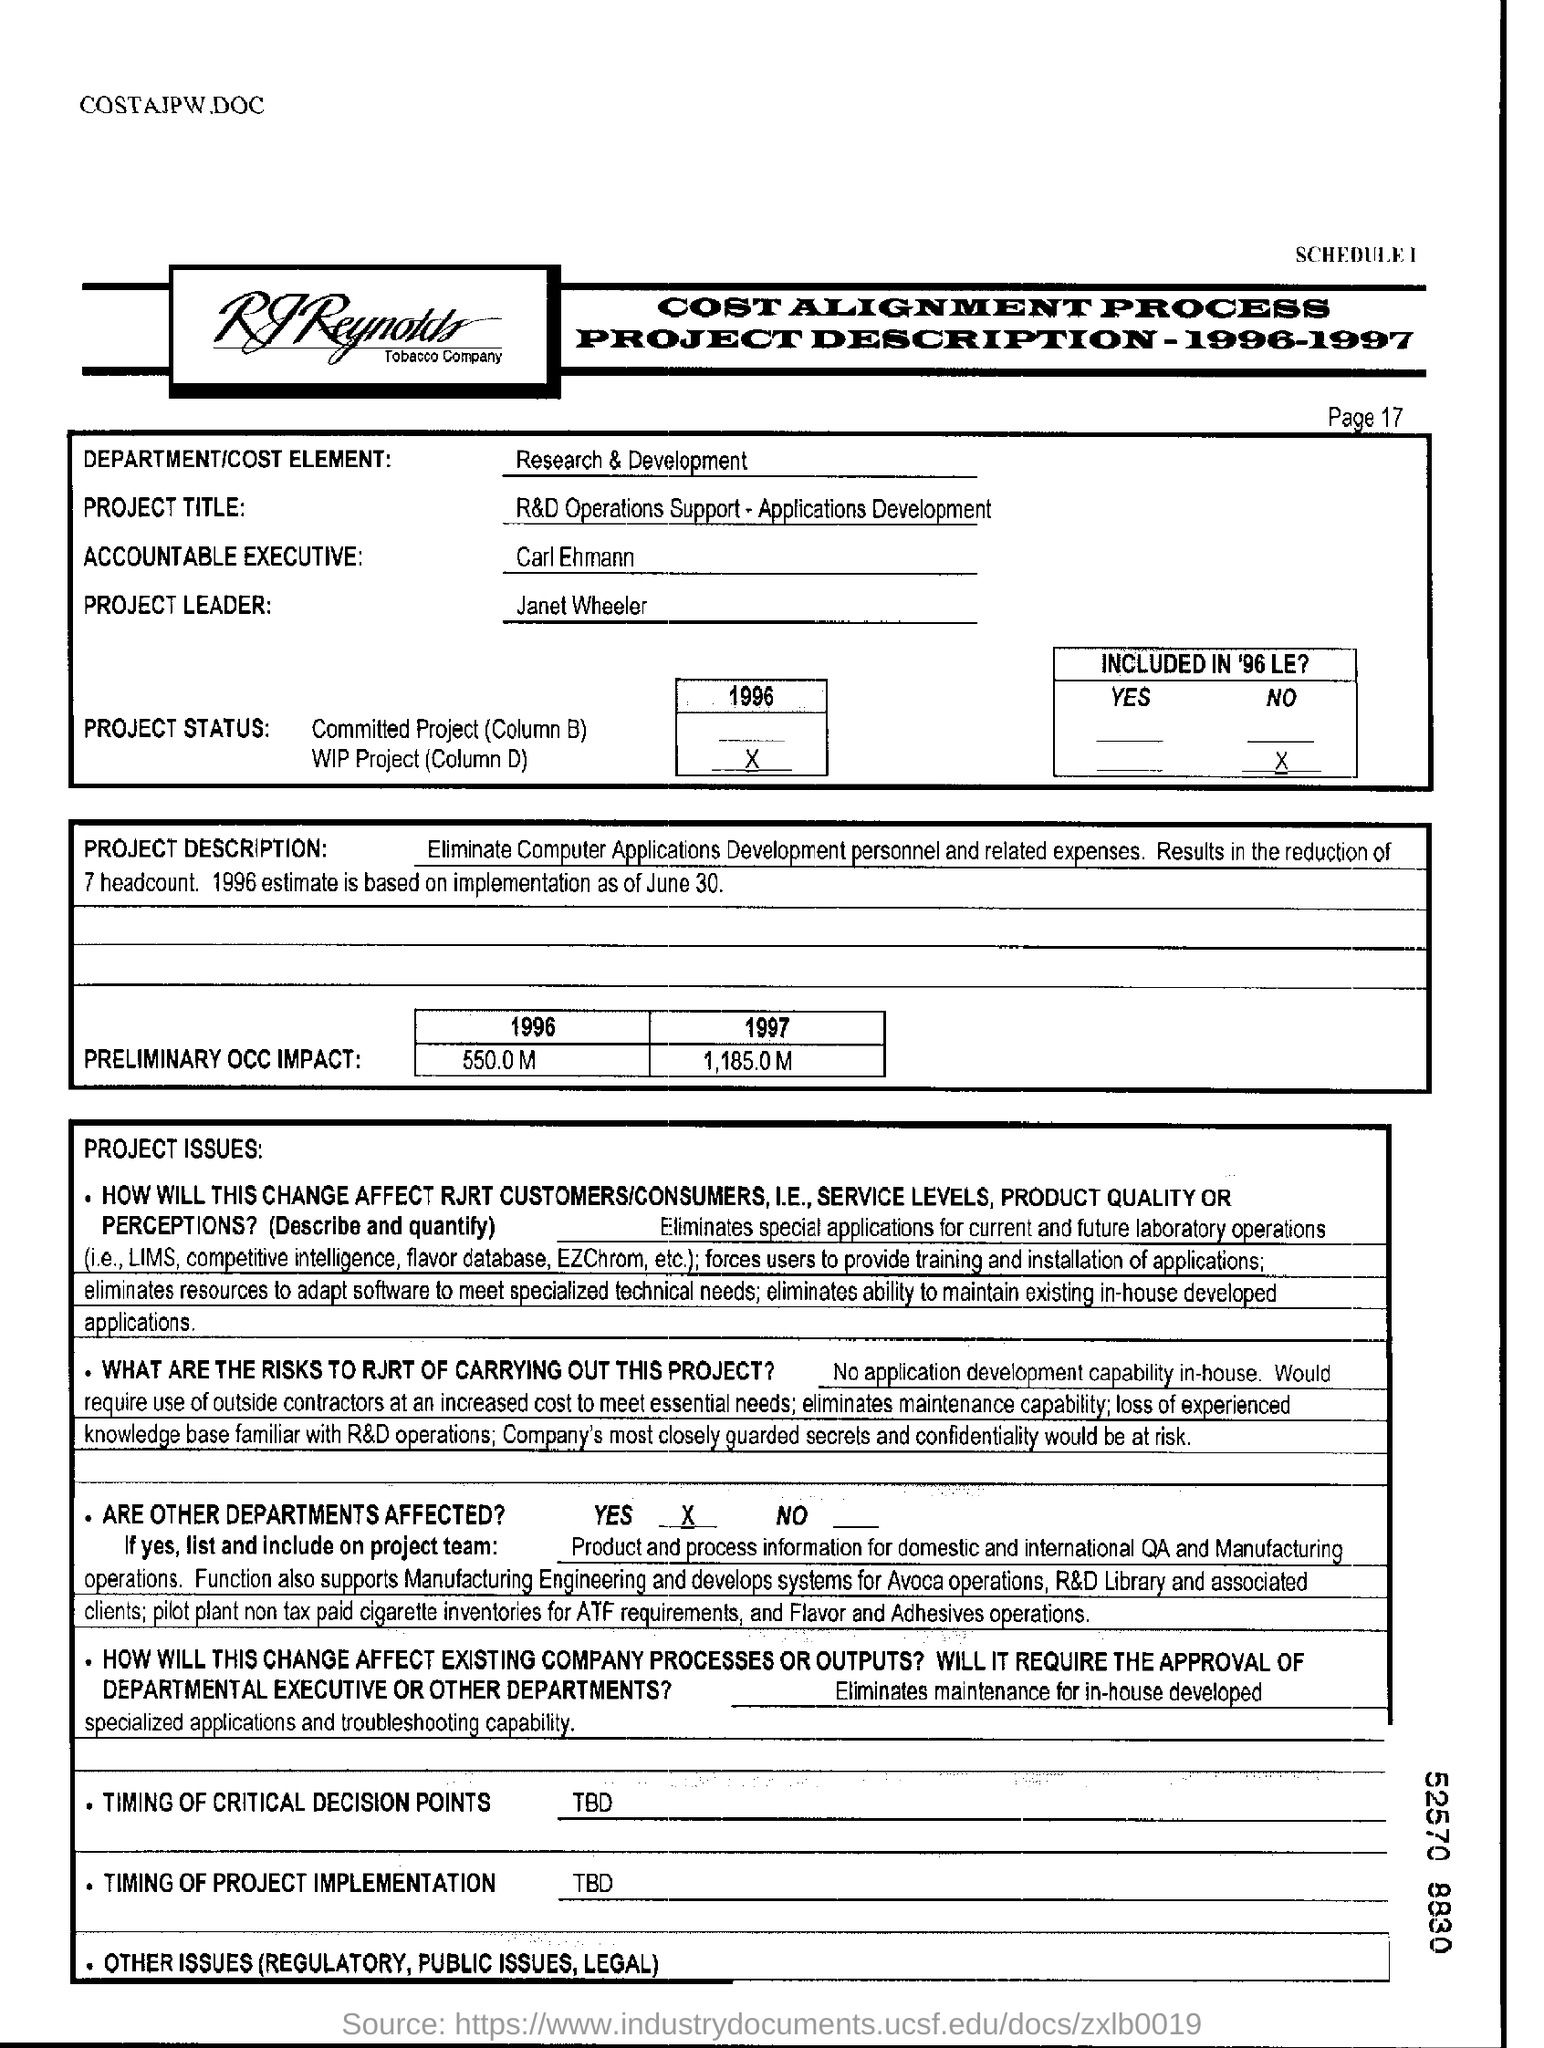What is the project title?
Make the answer very short. R&D Operations Support - Applications Development. Who is accountable excutive?
Ensure brevity in your answer.  Carl ehmann. Who is the project leader?
Your answer should be compact. Janet wheeler. Date present in the document?
Ensure brevity in your answer.  June 30. Who is the project leader?
Keep it short and to the point. Janet Wheeler. What is column d?
Make the answer very short. WIP project. What is the premliminary occ impact in the year 1996?
Ensure brevity in your answer.  550.0 M. What is the premliminary occ impact in the year 1997?
Offer a terse response. 1,185.0 M. 